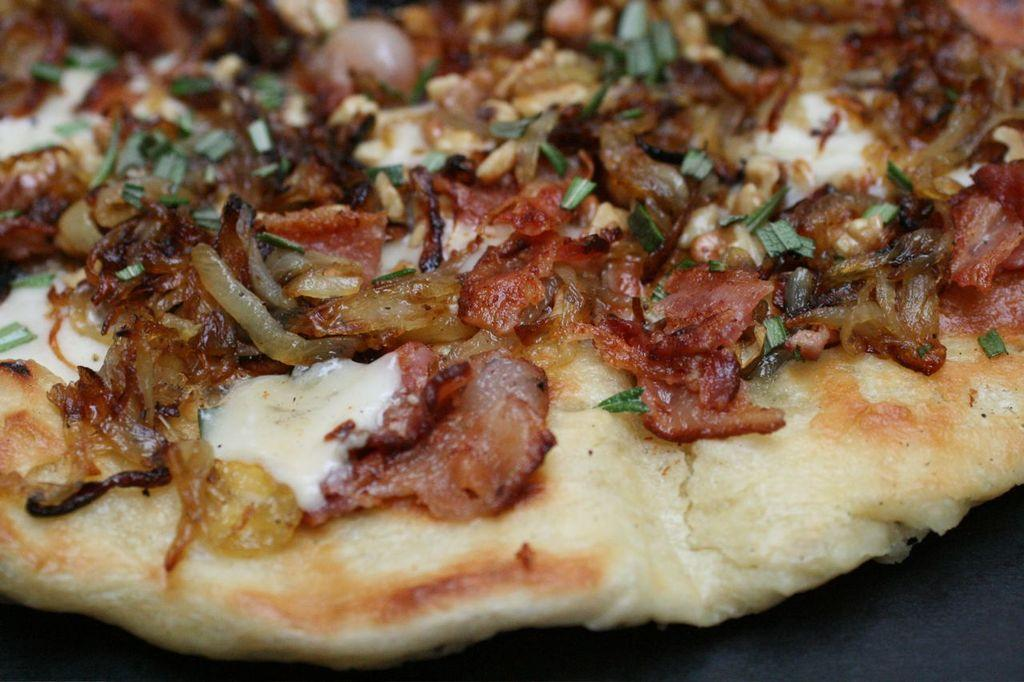What type of food is the main subject of the image? There is a pizza in the image. What is one of the main ingredients on the pizza? The pizza has cheese on it. What other toppings can be seen on the pizza? The pizza has onions and other veggies on it. What type of quince is being used as a topping on the pizza? There is no quince present on the pizza; it has cheese, onions, and other veggies as toppings. How does the pizza defend itself from an attack in the image? The pizza does not defend itself from an attack in the image; it is a static food item. 